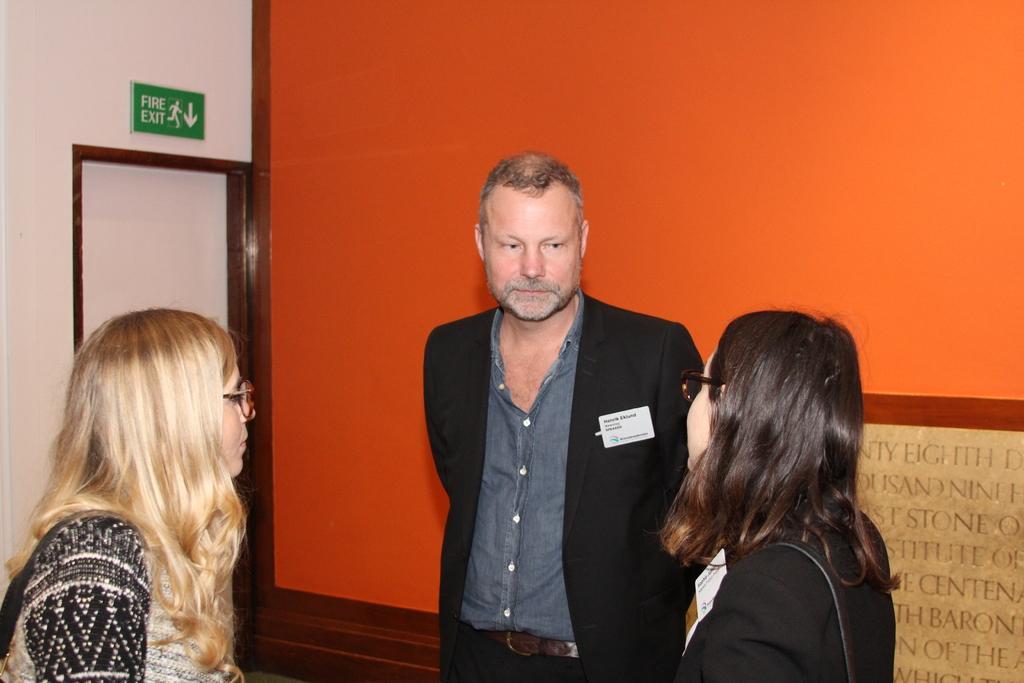Please provide a concise description of this image. In the image there are three people in the foreground and behind them there is a wall, on the left side there is a fire exit board and below the board there is a door. 